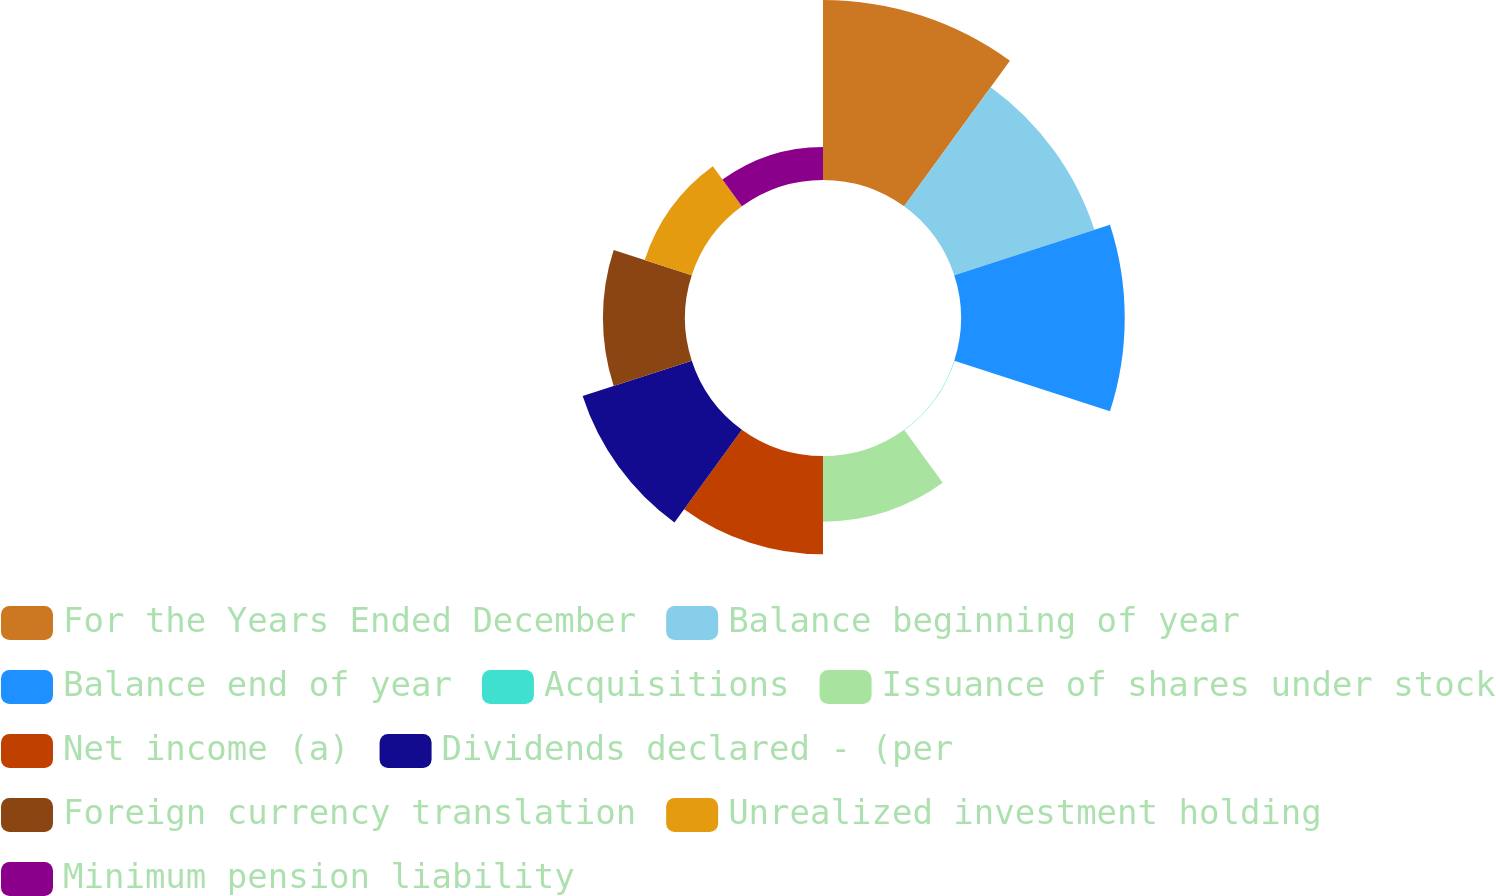<chart> <loc_0><loc_0><loc_500><loc_500><pie_chart><fcel>For the Years Ended December<fcel>Balance beginning of year<fcel>Balance end of year<fcel>Acquisitions<fcel>Issuance of shares under stock<fcel>Net income (a)<fcel>Dividends declared - (per<fcel>Foreign currency translation<fcel>Unrealized investment holding<fcel>Minimum pension liability<nl><fcel>19.25%<fcel>15.76%<fcel>17.51%<fcel>0.05%<fcel>7.03%<fcel>10.52%<fcel>12.27%<fcel>8.78%<fcel>5.29%<fcel>3.54%<nl></chart> 